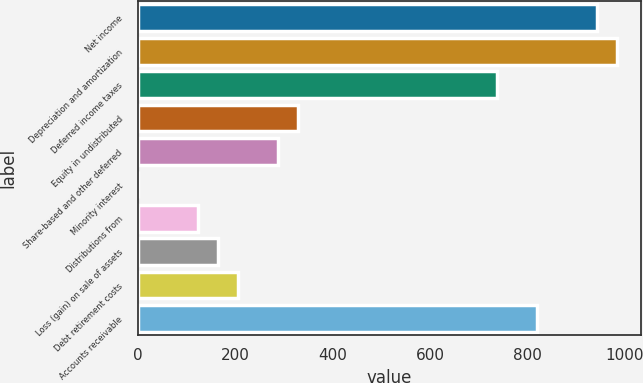Convert chart to OTSL. <chart><loc_0><loc_0><loc_500><loc_500><bar_chart><fcel>Net income<fcel>Depreciation and amortization<fcel>Deferred income taxes<fcel>Equity in undistributed<fcel>Share-based and other deferred<fcel>Minority interest<fcel>Distributions from<fcel>Loss (gain) on sale of assets<fcel>Debt retirement costs<fcel>Accounts receivable<nl><fcel>943.63<fcel>984.64<fcel>738.58<fcel>328.48<fcel>287.47<fcel>0.4<fcel>123.43<fcel>164.44<fcel>205.45<fcel>820.6<nl></chart> 